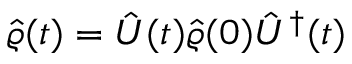Convert formula to latex. <formula><loc_0><loc_0><loc_500><loc_500>\hat { \varrho } ( t ) = \hat { U } ( t ) \hat { \varrho } ( 0 ) \hat { U } ^ { \dagger } ( t )</formula> 